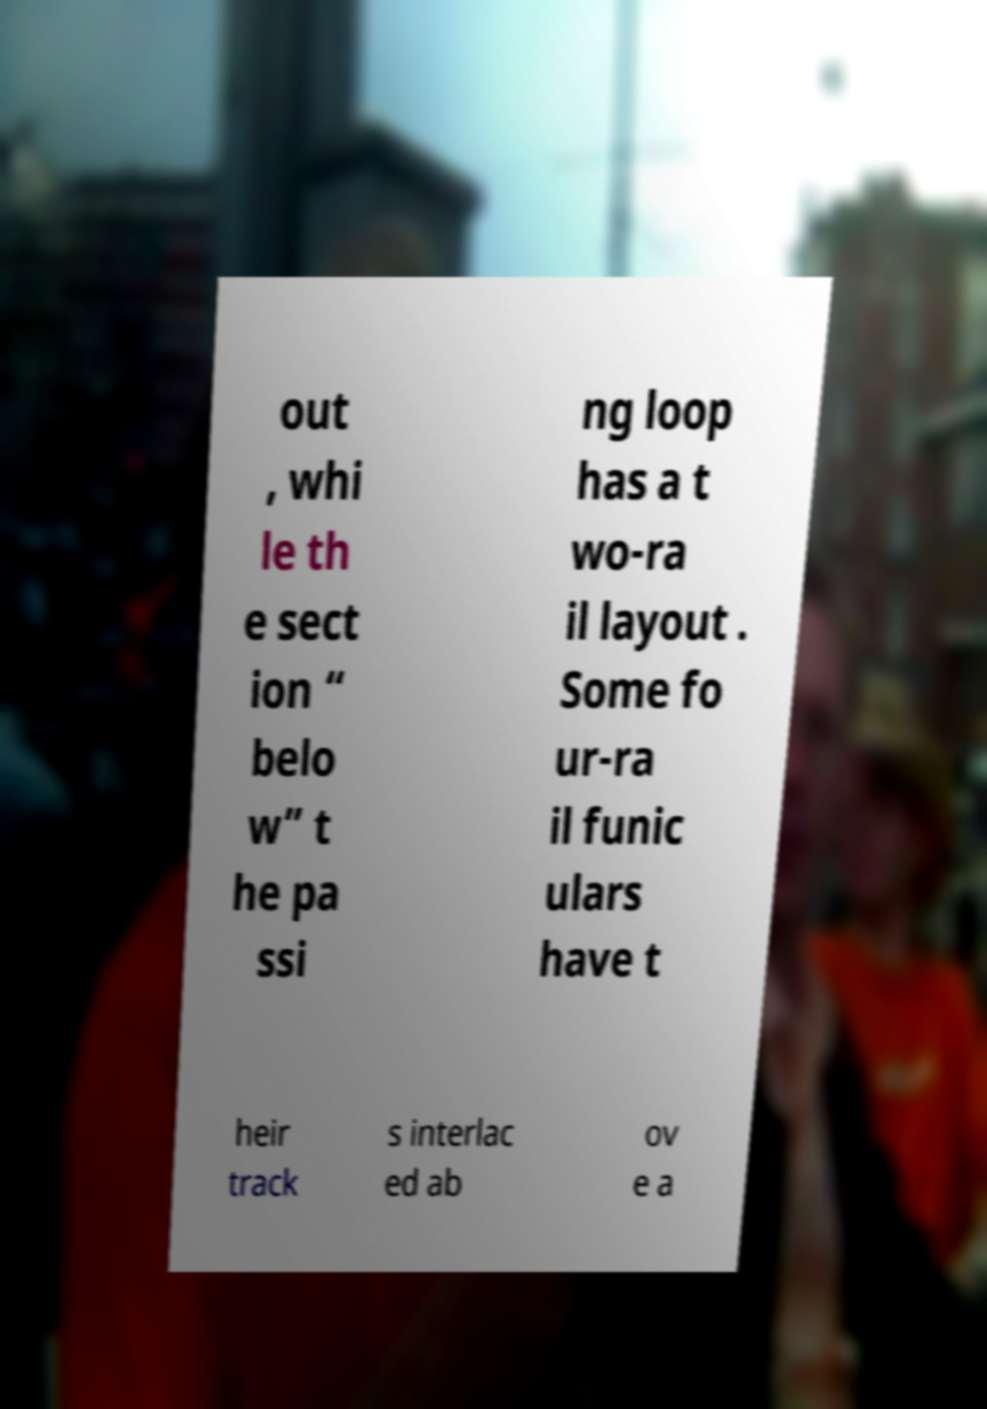Can you accurately transcribe the text from the provided image for me? out , whi le th e sect ion “ belo w” t he pa ssi ng loop has a t wo-ra il layout . Some fo ur-ra il funic ulars have t heir track s interlac ed ab ov e a 